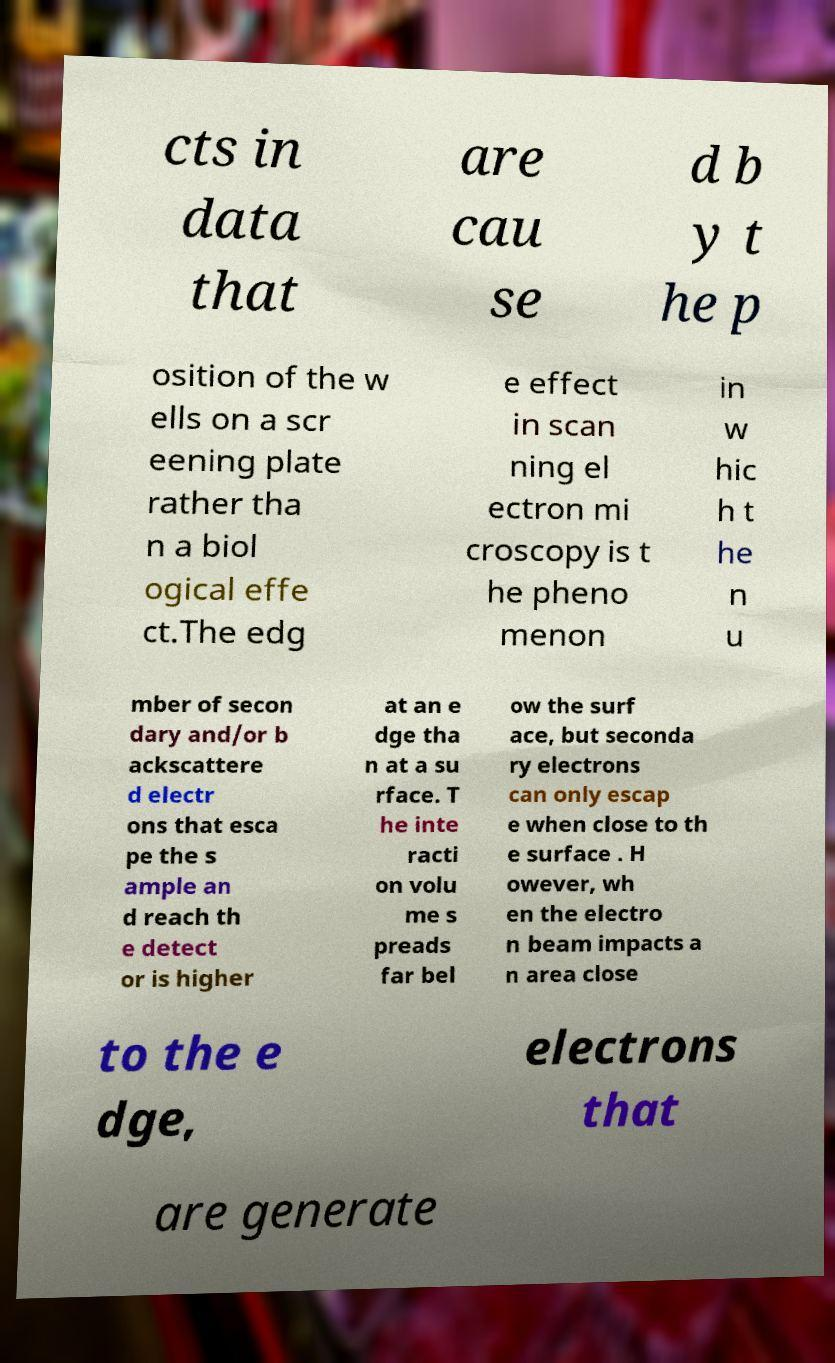For documentation purposes, I need the text within this image transcribed. Could you provide that? cts in data that are cau se d b y t he p osition of the w ells on a scr eening plate rather tha n a biol ogical effe ct.The edg e effect in scan ning el ectron mi croscopy is t he pheno menon in w hic h t he n u mber of secon dary and/or b ackscattere d electr ons that esca pe the s ample an d reach th e detect or is higher at an e dge tha n at a su rface. T he inte racti on volu me s preads far bel ow the surf ace, but seconda ry electrons can only escap e when close to th e surface . H owever, wh en the electro n beam impacts a n area close to the e dge, electrons that are generate 